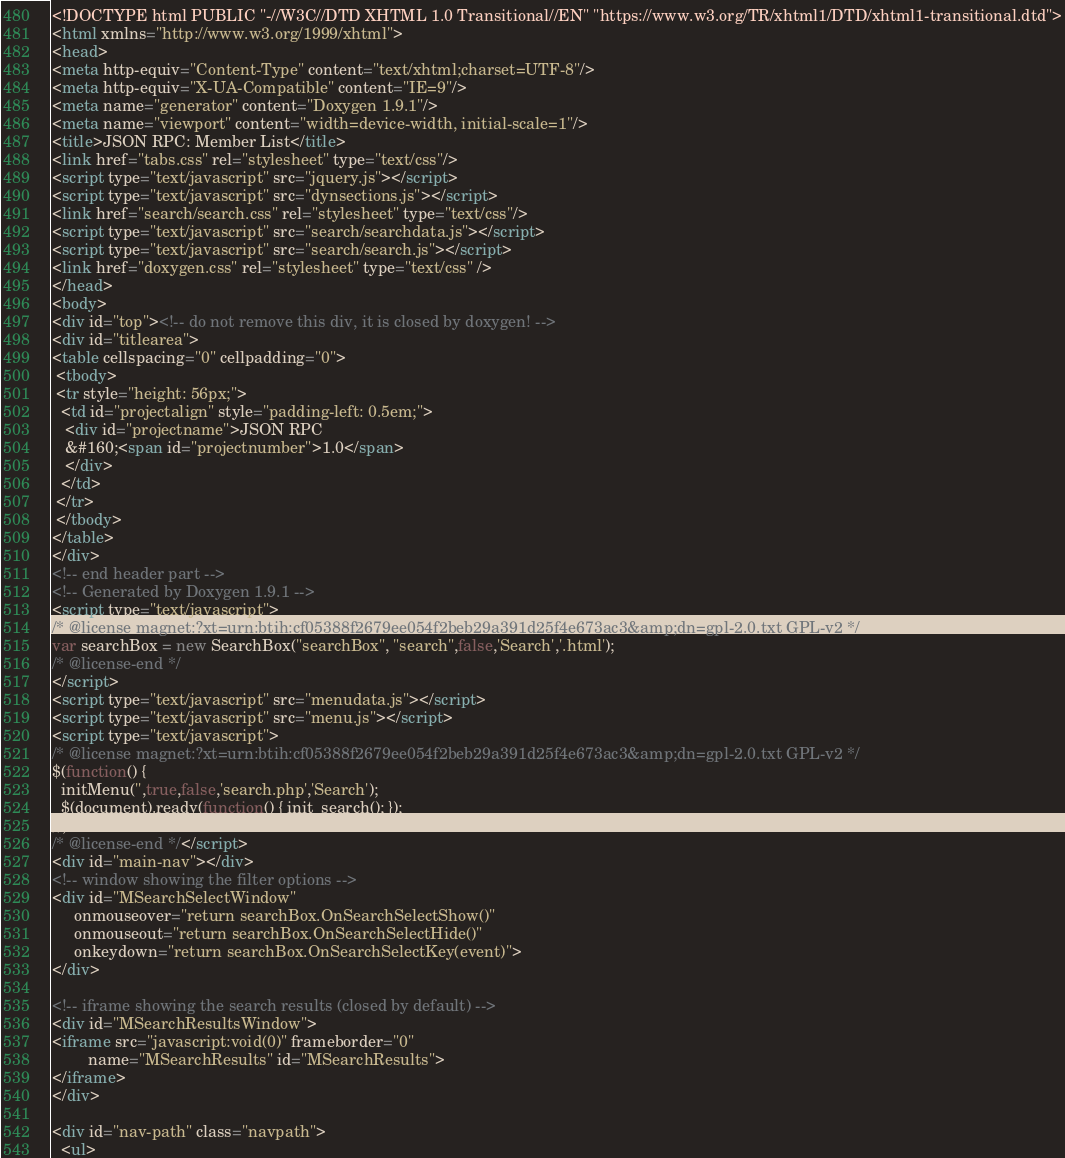<code> <loc_0><loc_0><loc_500><loc_500><_HTML_><!DOCTYPE html PUBLIC "-//W3C//DTD XHTML 1.0 Transitional//EN" "https://www.w3.org/TR/xhtml1/DTD/xhtml1-transitional.dtd">
<html xmlns="http://www.w3.org/1999/xhtml">
<head>
<meta http-equiv="Content-Type" content="text/xhtml;charset=UTF-8"/>
<meta http-equiv="X-UA-Compatible" content="IE=9"/>
<meta name="generator" content="Doxygen 1.9.1"/>
<meta name="viewport" content="width=device-width, initial-scale=1"/>
<title>JSON RPC: Member List</title>
<link href="tabs.css" rel="stylesheet" type="text/css"/>
<script type="text/javascript" src="jquery.js"></script>
<script type="text/javascript" src="dynsections.js"></script>
<link href="search/search.css" rel="stylesheet" type="text/css"/>
<script type="text/javascript" src="search/searchdata.js"></script>
<script type="text/javascript" src="search/search.js"></script>
<link href="doxygen.css" rel="stylesheet" type="text/css" />
</head>
<body>
<div id="top"><!-- do not remove this div, it is closed by doxygen! -->
<div id="titlearea">
<table cellspacing="0" cellpadding="0">
 <tbody>
 <tr style="height: 56px;">
  <td id="projectalign" style="padding-left: 0.5em;">
   <div id="projectname">JSON RPC
   &#160;<span id="projectnumber">1.0</span>
   </div>
  </td>
 </tr>
 </tbody>
</table>
</div>
<!-- end header part -->
<!-- Generated by Doxygen 1.9.1 -->
<script type="text/javascript">
/* @license magnet:?xt=urn:btih:cf05388f2679ee054f2beb29a391d25f4e673ac3&amp;dn=gpl-2.0.txt GPL-v2 */
var searchBox = new SearchBox("searchBox", "search",false,'Search','.html');
/* @license-end */
</script>
<script type="text/javascript" src="menudata.js"></script>
<script type="text/javascript" src="menu.js"></script>
<script type="text/javascript">
/* @license magnet:?xt=urn:btih:cf05388f2679ee054f2beb29a391d25f4e673ac3&amp;dn=gpl-2.0.txt GPL-v2 */
$(function() {
  initMenu('',true,false,'search.php','Search');
  $(document).ready(function() { init_search(); });
});
/* @license-end */</script>
<div id="main-nav"></div>
<!-- window showing the filter options -->
<div id="MSearchSelectWindow"
     onmouseover="return searchBox.OnSearchSelectShow()"
     onmouseout="return searchBox.OnSearchSelectHide()"
     onkeydown="return searchBox.OnSearchSelectKey(event)">
</div>

<!-- iframe showing the search results (closed by default) -->
<div id="MSearchResultsWindow">
<iframe src="javascript:void(0)" frameborder="0" 
        name="MSearchResults" id="MSearchResults">
</iframe>
</div>

<div id="nav-path" class="navpath">
  <ul></code> 